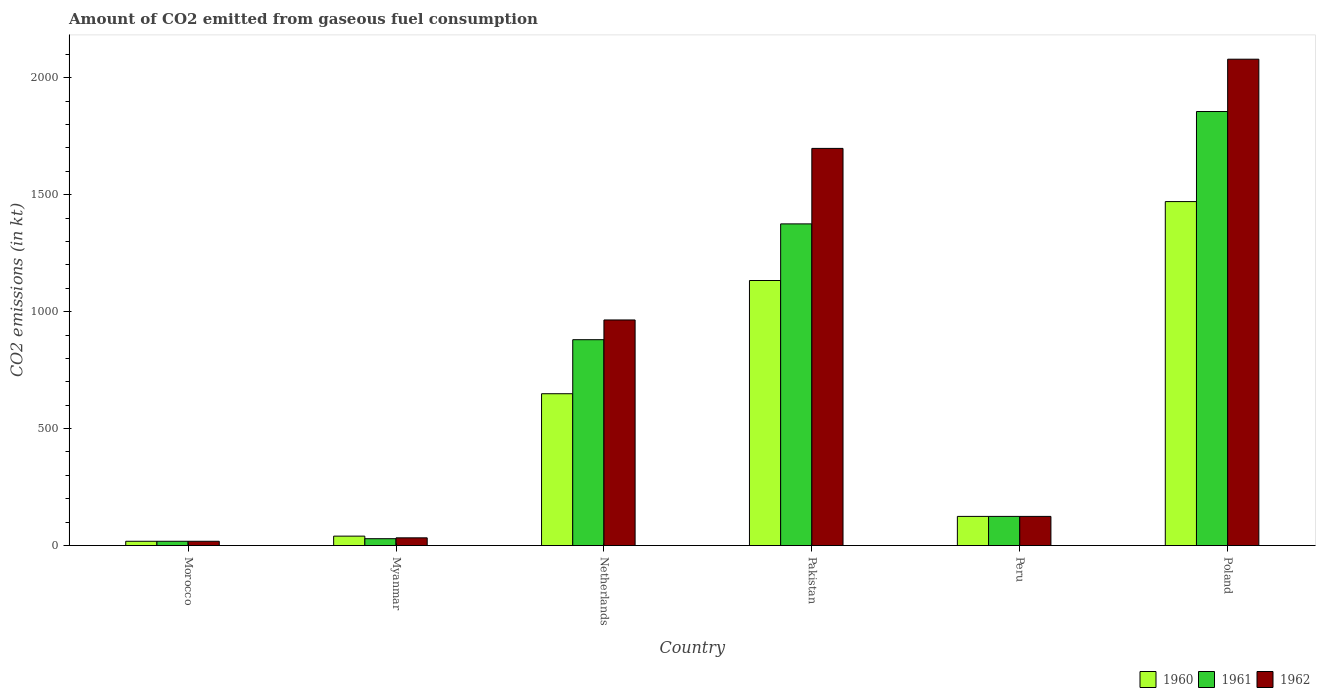Are the number of bars per tick equal to the number of legend labels?
Give a very brief answer. Yes. How many bars are there on the 5th tick from the left?
Ensure brevity in your answer.  3. What is the amount of CO2 emitted in 1962 in Pakistan?
Provide a short and direct response. 1697.82. Across all countries, what is the maximum amount of CO2 emitted in 1961?
Offer a terse response. 1855.5. Across all countries, what is the minimum amount of CO2 emitted in 1961?
Keep it short and to the point. 18.34. In which country was the amount of CO2 emitted in 1961 maximum?
Make the answer very short. Poland. In which country was the amount of CO2 emitted in 1962 minimum?
Keep it short and to the point. Morocco. What is the total amount of CO2 emitted in 1962 in the graph?
Offer a terse response. 4917.45. What is the difference between the amount of CO2 emitted in 1962 in Pakistan and that in Poland?
Your answer should be very brief. -381.37. What is the difference between the amount of CO2 emitted in 1960 in Myanmar and the amount of CO2 emitted in 1961 in Morocco?
Make the answer very short. 22. What is the average amount of CO2 emitted in 1960 per country?
Make the answer very short. 572.66. What is the difference between the amount of CO2 emitted of/in 1962 and amount of CO2 emitted of/in 1961 in Netherlands?
Ensure brevity in your answer.  84.34. In how many countries, is the amount of CO2 emitted in 1960 greater than 500 kt?
Ensure brevity in your answer.  3. What is the ratio of the amount of CO2 emitted in 1961 in Morocco to that in Peru?
Provide a succinct answer. 0.15. Is the amount of CO2 emitted in 1961 in Morocco less than that in Myanmar?
Offer a very short reply. Yes. Is the difference between the amount of CO2 emitted in 1962 in Morocco and Peru greater than the difference between the amount of CO2 emitted in 1961 in Morocco and Peru?
Keep it short and to the point. No. What is the difference between the highest and the second highest amount of CO2 emitted in 1961?
Offer a very short reply. -495.04. What is the difference between the highest and the lowest amount of CO2 emitted in 1962?
Ensure brevity in your answer.  2060.85. In how many countries, is the amount of CO2 emitted in 1960 greater than the average amount of CO2 emitted in 1960 taken over all countries?
Give a very brief answer. 3. What does the 2nd bar from the left in Myanmar represents?
Offer a very short reply. 1961. Are all the bars in the graph horizontal?
Give a very brief answer. No. Are the values on the major ticks of Y-axis written in scientific E-notation?
Provide a short and direct response. No. Does the graph contain grids?
Your answer should be very brief. No. What is the title of the graph?
Ensure brevity in your answer.  Amount of CO2 emitted from gaseous fuel consumption. What is the label or title of the X-axis?
Ensure brevity in your answer.  Country. What is the label or title of the Y-axis?
Provide a succinct answer. CO2 emissions (in kt). What is the CO2 emissions (in kt) in 1960 in Morocco?
Your answer should be compact. 18.34. What is the CO2 emissions (in kt) of 1961 in Morocco?
Your answer should be very brief. 18.34. What is the CO2 emissions (in kt) in 1962 in Morocco?
Provide a short and direct response. 18.34. What is the CO2 emissions (in kt) of 1960 in Myanmar?
Make the answer very short. 40.34. What is the CO2 emissions (in kt) in 1961 in Myanmar?
Your answer should be compact. 29.34. What is the CO2 emissions (in kt) in 1962 in Myanmar?
Your answer should be very brief. 33. What is the CO2 emissions (in kt) in 1960 in Netherlands?
Make the answer very short. 649.06. What is the CO2 emissions (in kt) of 1961 in Netherlands?
Offer a very short reply. 880.08. What is the CO2 emissions (in kt) in 1962 in Netherlands?
Provide a succinct answer. 964.42. What is the CO2 emissions (in kt) in 1960 in Pakistan?
Your response must be concise. 1133.1. What is the CO2 emissions (in kt) of 1961 in Pakistan?
Your response must be concise. 1375.12. What is the CO2 emissions (in kt) in 1962 in Pakistan?
Your answer should be very brief. 1697.82. What is the CO2 emissions (in kt) of 1960 in Peru?
Give a very brief answer. 124.68. What is the CO2 emissions (in kt) of 1961 in Peru?
Your answer should be very brief. 124.68. What is the CO2 emissions (in kt) in 1962 in Peru?
Provide a short and direct response. 124.68. What is the CO2 emissions (in kt) in 1960 in Poland?
Give a very brief answer. 1470.47. What is the CO2 emissions (in kt) in 1961 in Poland?
Offer a very short reply. 1855.5. What is the CO2 emissions (in kt) in 1962 in Poland?
Ensure brevity in your answer.  2079.19. Across all countries, what is the maximum CO2 emissions (in kt) of 1960?
Ensure brevity in your answer.  1470.47. Across all countries, what is the maximum CO2 emissions (in kt) in 1961?
Your answer should be compact. 1855.5. Across all countries, what is the maximum CO2 emissions (in kt) of 1962?
Offer a terse response. 2079.19. Across all countries, what is the minimum CO2 emissions (in kt) of 1960?
Offer a terse response. 18.34. Across all countries, what is the minimum CO2 emissions (in kt) in 1961?
Offer a terse response. 18.34. Across all countries, what is the minimum CO2 emissions (in kt) in 1962?
Give a very brief answer. 18.34. What is the total CO2 emissions (in kt) in 1960 in the graph?
Make the answer very short. 3435.98. What is the total CO2 emissions (in kt) in 1961 in the graph?
Provide a succinct answer. 4283.06. What is the total CO2 emissions (in kt) in 1962 in the graph?
Make the answer very short. 4917.45. What is the difference between the CO2 emissions (in kt) in 1960 in Morocco and that in Myanmar?
Give a very brief answer. -22. What is the difference between the CO2 emissions (in kt) of 1961 in Morocco and that in Myanmar?
Provide a short and direct response. -11. What is the difference between the CO2 emissions (in kt) in 1962 in Morocco and that in Myanmar?
Provide a short and direct response. -14.67. What is the difference between the CO2 emissions (in kt) of 1960 in Morocco and that in Netherlands?
Provide a succinct answer. -630.72. What is the difference between the CO2 emissions (in kt) in 1961 in Morocco and that in Netherlands?
Ensure brevity in your answer.  -861.75. What is the difference between the CO2 emissions (in kt) in 1962 in Morocco and that in Netherlands?
Your answer should be compact. -946.09. What is the difference between the CO2 emissions (in kt) of 1960 in Morocco and that in Pakistan?
Make the answer very short. -1114.77. What is the difference between the CO2 emissions (in kt) in 1961 in Morocco and that in Pakistan?
Your response must be concise. -1356.79. What is the difference between the CO2 emissions (in kt) of 1962 in Morocco and that in Pakistan?
Give a very brief answer. -1679.49. What is the difference between the CO2 emissions (in kt) of 1960 in Morocco and that in Peru?
Your answer should be very brief. -106.34. What is the difference between the CO2 emissions (in kt) of 1961 in Morocco and that in Peru?
Provide a succinct answer. -106.34. What is the difference between the CO2 emissions (in kt) in 1962 in Morocco and that in Peru?
Provide a succinct answer. -106.34. What is the difference between the CO2 emissions (in kt) in 1960 in Morocco and that in Poland?
Your response must be concise. -1452.13. What is the difference between the CO2 emissions (in kt) in 1961 in Morocco and that in Poland?
Provide a succinct answer. -1837.17. What is the difference between the CO2 emissions (in kt) of 1962 in Morocco and that in Poland?
Your answer should be very brief. -2060.85. What is the difference between the CO2 emissions (in kt) in 1960 in Myanmar and that in Netherlands?
Make the answer very short. -608.72. What is the difference between the CO2 emissions (in kt) of 1961 in Myanmar and that in Netherlands?
Offer a terse response. -850.74. What is the difference between the CO2 emissions (in kt) in 1962 in Myanmar and that in Netherlands?
Your answer should be compact. -931.42. What is the difference between the CO2 emissions (in kt) of 1960 in Myanmar and that in Pakistan?
Give a very brief answer. -1092.77. What is the difference between the CO2 emissions (in kt) in 1961 in Myanmar and that in Pakistan?
Give a very brief answer. -1345.79. What is the difference between the CO2 emissions (in kt) in 1962 in Myanmar and that in Pakistan?
Offer a terse response. -1664.82. What is the difference between the CO2 emissions (in kt) in 1960 in Myanmar and that in Peru?
Keep it short and to the point. -84.34. What is the difference between the CO2 emissions (in kt) in 1961 in Myanmar and that in Peru?
Your response must be concise. -95.34. What is the difference between the CO2 emissions (in kt) of 1962 in Myanmar and that in Peru?
Offer a very short reply. -91.67. What is the difference between the CO2 emissions (in kt) in 1960 in Myanmar and that in Poland?
Make the answer very short. -1430.13. What is the difference between the CO2 emissions (in kt) in 1961 in Myanmar and that in Poland?
Keep it short and to the point. -1826.17. What is the difference between the CO2 emissions (in kt) of 1962 in Myanmar and that in Poland?
Keep it short and to the point. -2046.19. What is the difference between the CO2 emissions (in kt) of 1960 in Netherlands and that in Pakistan?
Your response must be concise. -484.04. What is the difference between the CO2 emissions (in kt) in 1961 in Netherlands and that in Pakistan?
Your answer should be compact. -495.05. What is the difference between the CO2 emissions (in kt) in 1962 in Netherlands and that in Pakistan?
Give a very brief answer. -733.4. What is the difference between the CO2 emissions (in kt) in 1960 in Netherlands and that in Peru?
Offer a very short reply. 524.38. What is the difference between the CO2 emissions (in kt) in 1961 in Netherlands and that in Peru?
Ensure brevity in your answer.  755.4. What is the difference between the CO2 emissions (in kt) in 1962 in Netherlands and that in Peru?
Offer a terse response. 839.74. What is the difference between the CO2 emissions (in kt) of 1960 in Netherlands and that in Poland?
Your answer should be compact. -821.41. What is the difference between the CO2 emissions (in kt) of 1961 in Netherlands and that in Poland?
Your answer should be very brief. -975.42. What is the difference between the CO2 emissions (in kt) in 1962 in Netherlands and that in Poland?
Provide a short and direct response. -1114.77. What is the difference between the CO2 emissions (in kt) of 1960 in Pakistan and that in Peru?
Your answer should be very brief. 1008.42. What is the difference between the CO2 emissions (in kt) of 1961 in Pakistan and that in Peru?
Make the answer very short. 1250.45. What is the difference between the CO2 emissions (in kt) of 1962 in Pakistan and that in Peru?
Make the answer very short. 1573.14. What is the difference between the CO2 emissions (in kt) of 1960 in Pakistan and that in Poland?
Offer a terse response. -337.36. What is the difference between the CO2 emissions (in kt) in 1961 in Pakistan and that in Poland?
Keep it short and to the point. -480.38. What is the difference between the CO2 emissions (in kt) of 1962 in Pakistan and that in Poland?
Give a very brief answer. -381.37. What is the difference between the CO2 emissions (in kt) of 1960 in Peru and that in Poland?
Your answer should be very brief. -1345.79. What is the difference between the CO2 emissions (in kt) in 1961 in Peru and that in Poland?
Make the answer very short. -1730.82. What is the difference between the CO2 emissions (in kt) of 1962 in Peru and that in Poland?
Provide a succinct answer. -1954.51. What is the difference between the CO2 emissions (in kt) in 1960 in Morocco and the CO2 emissions (in kt) in 1961 in Myanmar?
Offer a very short reply. -11. What is the difference between the CO2 emissions (in kt) of 1960 in Morocco and the CO2 emissions (in kt) of 1962 in Myanmar?
Your response must be concise. -14.67. What is the difference between the CO2 emissions (in kt) in 1961 in Morocco and the CO2 emissions (in kt) in 1962 in Myanmar?
Make the answer very short. -14.67. What is the difference between the CO2 emissions (in kt) in 1960 in Morocco and the CO2 emissions (in kt) in 1961 in Netherlands?
Your response must be concise. -861.75. What is the difference between the CO2 emissions (in kt) in 1960 in Morocco and the CO2 emissions (in kt) in 1962 in Netherlands?
Give a very brief answer. -946.09. What is the difference between the CO2 emissions (in kt) of 1961 in Morocco and the CO2 emissions (in kt) of 1962 in Netherlands?
Provide a short and direct response. -946.09. What is the difference between the CO2 emissions (in kt) in 1960 in Morocco and the CO2 emissions (in kt) in 1961 in Pakistan?
Offer a very short reply. -1356.79. What is the difference between the CO2 emissions (in kt) in 1960 in Morocco and the CO2 emissions (in kt) in 1962 in Pakistan?
Make the answer very short. -1679.49. What is the difference between the CO2 emissions (in kt) of 1961 in Morocco and the CO2 emissions (in kt) of 1962 in Pakistan?
Your answer should be very brief. -1679.49. What is the difference between the CO2 emissions (in kt) in 1960 in Morocco and the CO2 emissions (in kt) in 1961 in Peru?
Offer a very short reply. -106.34. What is the difference between the CO2 emissions (in kt) in 1960 in Morocco and the CO2 emissions (in kt) in 1962 in Peru?
Your answer should be very brief. -106.34. What is the difference between the CO2 emissions (in kt) of 1961 in Morocco and the CO2 emissions (in kt) of 1962 in Peru?
Offer a terse response. -106.34. What is the difference between the CO2 emissions (in kt) of 1960 in Morocco and the CO2 emissions (in kt) of 1961 in Poland?
Keep it short and to the point. -1837.17. What is the difference between the CO2 emissions (in kt) in 1960 in Morocco and the CO2 emissions (in kt) in 1962 in Poland?
Ensure brevity in your answer.  -2060.85. What is the difference between the CO2 emissions (in kt) of 1961 in Morocco and the CO2 emissions (in kt) of 1962 in Poland?
Offer a terse response. -2060.85. What is the difference between the CO2 emissions (in kt) in 1960 in Myanmar and the CO2 emissions (in kt) in 1961 in Netherlands?
Ensure brevity in your answer.  -839.74. What is the difference between the CO2 emissions (in kt) of 1960 in Myanmar and the CO2 emissions (in kt) of 1962 in Netherlands?
Your response must be concise. -924.08. What is the difference between the CO2 emissions (in kt) in 1961 in Myanmar and the CO2 emissions (in kt) in 1962 in Netherlands?
Your answer should be very brief. -935.09. What is the difference between the CO2 emissions (in kt) in 1960 in Myanmar and the CO2 emissions (in kt) in 1961 in Pakistan?
Your answer should be compact. -1334.79. What is the difference between the CO2 emissions (in kt) in 1960 in Myanmar and the CO2 emissions (in kt) in 1962 in Pakistan?
Offer a terse response. -1657.48. What is the difference between the CO2 emissions (in kt) in 1961 in Myanmar and the CO2 emissions (in kt) in 1962 in Pakistan?
Make the answer very short. -1668.48. What is the difference between the CO2 emissions (in kt) of 1960 in Myanmar and the CO2 emissions (in kt) of 1961 in Peru?
Make the answer very short. -84.34. What is the difference between the CO2 emissions (in kt) of 1960 in Myanmar and the CO2 emissions (in kt) of 1962 in Peru?
Keep it short and to the point. -84.34. What is the difference between the CO2 emissions (in kt) in 1961 in Myanmar and the CO2 emissions (in kt) in 1962 in Peru?
Give a very brief answer. -95.34. What is the difference between the CO2 emissions (in kt) of 1960 in Myanmar and the CO2 emissions (in kt) of 1961 in Poland?
Give a very brief answer. -1815.16. What is the difference between the CO2 emissions (in kt) of 1960 in Myanmar and the CO2 emissions (in kt) of 1962 in Poland?
Offer a terse response. -2038.85. What is the difference between the CO2 emissions (in kt) in 1961 in Myanmar and the CO2 emissions (in kt) in 1962 in Poland?
Your answer should be compact. -2049.85. What is the difference between the CO2 emissions (in kt) of 1960 in Netherlands and the CO2 emissions (in kt) of 1961 in Pakistan?
Make the answer very short. -726.07. What is the difference between the CO2 emissions (in kt) in 1960 in Netherlands and the CO2 emissions (in kt) in 1962 in Pakistan?
Your answer should be very brief. -1048.76. What is the difference between the CO2 emissions (in kt) of 1961 in Netherlands and the CO2 emissions (in kt) of 1962 in Pakistan?
Keep it short and to the point. -817.74. What is the difference between the CO2 emissions (in kt) in 1960 in Netherlands and the CO2 emissions (in kt) in 1961 in Peru?
Give a very brief answer. 524.38. What is the difference between the CO2 emissions (in kt) of 1960 in Netherlands and the CO2 emissions (in kt) of 1962 in Peru?
Keep it short and to the point. 524.38. What is the difference between the CO2 emissions (in kt) in 1961 in Netherlands and the CO2 emissions (in kt) in 1962 in Peru?
Ensure brevity in your answer.  755.4. What is the difference between the CO2 emissions (in kt) of 1960 in Netherlands and the CO2 emissions (in kt) of 1961 in Poland?
Provide a succinct answer. -1206.44. What is the difference between the CO2 emissions (in kt) in 1960 in Netherlands and the CO2 emissions (in kt) in 1962 in Poland?
Offer a very short reply. -1430.13. What is the difference between the CO2 emissions (in kt) in 1961 in Netherlands and the CO2 emissions (in kt) in 1962 in Poland?
Your response must be concise. -1199.11. What is the difference between the CO2 emissions (in kt) in 1960 in Pakistan and the CO2 emissions (in kt) in 1961 in Peru?
Your response must be concise. 1008.42. What is the difference between the CO2 emissions (in kt) in 1960 in Pakistan and the CO2 emissions (in kt) in 1962 in Peru?
Offer a terse response. 1008.42. What is the difference between the CO2 emissions (in kt) of 1961 in Pakistan and the CO2 emissions (in kt) of 1962 in Peru?
Offer a terse response. 1250.45. What is the difference between the CO2 emissions (in kt) of 1960 in Pakistan and the CO2 emissions (in kt) of 1961 in Poland?
Give a very brief answer. -722.4. What is the difference between the CO2 emissions (in kt) of 1960 in Pakistan and the CO2 emissions (in kt) of 1962 in Poland?
Make the answer very short. -946.09. What is the difference between the CO2 emissions (in kt) in 1961 in Pakistan and the CO2 emissions (in kt) in 1962 in Poland?
Your answer should be compact. -704.06. What is the difference between the CO2 emissions (in kt) in 1960 in Peru and the CO2 emissions (in kt) in 1961 in Poland?
Provide a succinct answer. -1730.82. What is the difference between the CO2 emissions (in kt) in 1960 in Peru and the CO2 emissions (in kt) in 1962 in Poland?
Provide a succinct answer. -1954.51. What is the difference between the CO2 emissions (in kt) in 1961 in Peru and the CO2 emissions (in kt) in 1962 in Poland?
Ensure brevity in your answer.  -1954.51. What is the average CO2 emissions (in kt) of 1960 per country?
Offer a terse response. 572.66. What is the average CO2 emissions (in kt) of 1961 per country?
Give a very brief answer. 713.84. What is the average CO2 emissions (in kt) in 1962 per country?
Your answer should be compact. 819.57. What is the difference between the CO2 emissions (in kt) of 1960 and CO2 emissions (in kt) of 1961 in Myanmar?
Your response must be concise. 11. What is the difference between the CO2 emissions (in kt) of 1960 and CO2 emissions (in kt) of 1962 in Myanmar?
Ensure brevity in your answer.  7.33. What is the difference between the CO2 emissions (in kt) in 1961 and CO2 emissions (in kt) in 1962 in Myanmar?
Make the answer very short. -3.67. What is the difference between the CO2 emissions (in kt) in 1960 and CO2 emissions (in kt) in 1961 in Netherlands?
Offer a very short reply. -231.02. What is the difference between the CO2 emissions (in kt) in 1960 and CO2 emissions (in kt) in 1962 in Netherlands?
Offer a very short reply. -315.36. What is the difference between the CO2 emissions (in kt) in 1961 and CO2 emissions (in kt) in 1962 in Netherlands?
Your response must be concise. -84.34. What is the difference between the CO2 emissions (in kt) of 1960 and CO2 emissions (in kt) of 1961 in Pakistan?
Your answer should be very brief. -242.02. What is the difference between the CO2 emissions (in kt) of 1960 and CO2 emissions (in kt) of 1962 in Pakistan?
Offer a terse response. -564.72. What is the difference between the CO2 emissions (in kt) of 1961 and CO2 emissions (in kt) of 1962 in Pakistan?
Offer a terse response. -322.7. What is the difference between the CO2 emissions (in kt) of 1960 and CO2 emissions (in kt) of 1961 in Peru?
Ensure brevity in your answer.  0. What is the difference between the CO2 emissions (in kt) of 1960 and CO2 emissions (in kt) of 1962 in Peru?
Offer a very short reply. 0. What is the difference between the CO2 emissions (in kt) of 1961 and CO2 emissions (in kt) of 1962 in Peru?
Make the answer very short. 0. What is the difference between the CO2 emissions (in kt) in 1960 and CO2 emissions (in kt) in 1961 in Poland?
Provide a short and direct response. -385.04. What is the difference between the CO2 emissions (in kt) of 1960 and CO2 emissions (in kt) of 1962 in Poland?
Ensure brevity in your answer.  -608.72. What is the difference between the CO2 emissions (in kt) in 1961 and CO2 emissions (in kt) in 1962 in Poland?
Your answer should be very brief. -223.69. What is the ratio of the CO2 emissions (in kt) of 1960 in Morocco to that in Myanmar?
Your response must be concise. 0.45. What is the ratio of the CO2 emissions (in kt) in 1962 in Morocco to that in Myanmar?
Your answer should be compact. 0.56. What is the ratio of the CO2 emissions (in kt) of 1960 in Morocco to that in Netherlands?
Your response must be concise. 0.03. What is the ratio of the CO2 emissions (in kt) of 1961 in Morocco to that in Netherlands?
Provide a succinct answer. 0.02. What is the ratio of the CO2 emissions (in kt) in 1962 in Morocco to that in Netherlands?
Your response must be concise. 0.02. What is the ratio of the CO2 emissions (in kt) in 1960 in Morocco to that in Pakistan?
Keep it short and to the point. 0.02. What is the ratio of the CO2 emissions (in kt) of 1961 in Morocco to that in Pakistan?
Provide a succinct answer. 0.01. What is the ratio of the CO2 emissions (in kt) in 1962 in Morocco to that in Pakistan?
Your answer should be very brief. 0.01. What is the ratio of the CO2 emissions (in kt) in 1960 in Morocco to that in Peru?
Make the answer very short. 0.15. What is the ratio of the CO2 emissions (in kt) of 1961 in Morocco to that in Peru?
Provide a succinct answer. 0.15. What is the ratio of the CO2 emissions (in kt) of 1962 in Morocco to that in Peru?
Offer a very short reply. 0.15. What is the ratio of the CO2 emissions (in kt) of 1960 in Morocco to that in Poland?
Make the answer very short. 0.01. What is the ratio of the CO2 emissions (in kt) in 1961 in Morocco to that in Poland?
Provide a succinct answer. 0.01. What is the ratio of the CO2 emissions (in kt) in 1962 in Morocco to that in Poland?
Keep it short and to the point. 0.01. What is the ratio of the CO2 emissions (in kt) in 1960 in Myanmar to that in Netherlands?
Make the answer very short. 0.06. What is the ratio of the CO2 emissions (in kt) in 1962 in Myanmar to that in Netherlands?
Offer a terse response. 0.03. What is the ratio of the CO2 emissions (in kt) of 1960 in Myanmar to that in Pakistan?
Your response must be concise. 0.04. What is the ratio of the CO2 emissions (in kt) in 1961 in Myanmar to that in Pakistan?
Provide a succinct answer. 0.02. What is the ratio of the CO2 emissions (in kt) of 1962 in Myanmar to that in Pakistan?
Your answer should be compact. 0.02. What is the ratio of the CO2 emissions (in kt) of 1960 in Myanmar to that in Peru?
Make the answer very short. 0.32. What is the ratio of the CO2 emissions (in kt) of 1961 in Myanmar to that in Peru?
Your answer should be very brief. 0.24. What is the ratio of the CO2 emissions (in kt) of 1962 in Myanmar to that in Peru?
Give a very brief answer. 0.26. What is the ratio of the CO2 emissions (in kt) in 1960 in Myanmar to that in Poland?
Provide a succinct answer. 0.03. What is the ratio of the CO2 emissions (in kt) in 1961 in Myanmar to that in Poland?
Make the answer very short. 0.02. What is the ratio of the CO2 emissions (in kt) of 1962 in Myanmar to that in Poland?
Make the answer very short. 0.02. What is the ratio of the CO2 emissions (in kt) of 1960 in Netherlands to that in Pakistan?
Provide a succinct answer. 0.57. What is the ratio of the CO2 emissions (in kt) of 1961 in Netherlands to that in Pakistan?
Provide a succinct answer. 0.64. What is the ratio of the CO2 emissions (in kt) of 1962 in Netherlands to that in Pakistan?
Make the answer very short. 0.57. What is the ratio of the CO2 emissions (in kt) of 1960 in Netherlands to that in Peru?
Ensure brevity in your answer.  5.21. What is the ratio of the CO2 emissions (in kt) of 1961 in Netherlands to that in Peru?
Keep it short and to the point. 7.06. What is the ratio of the CO2 emissions (in kt) of 1962 in Netherlands to that in Peru?
Your response must be concise. 7.74. What is the ratio of the CO2 emissions (in kt) of 1960 in Netherlands to that in Poland?
Your response must be concise. 0.44. What is the ratio of the CO2 emissions (in kt) of 1961 in Netherlands to that in Poland?
Offer a very short reply. 0.47. What is the ratio of the CO2 emissions (in kt) in 1962 in Netherlands to that in Poland?
Offer a terse response. 0.46. What is the ratio of the CO2 emissions (in kt) in 1960 in Pakistan to that in Peru?
Offer a terse response. 9.09. What is the ratio of the CO2 emissions (in kt) in 1961 in Pakistan to that in Peru?
Ensure brevity in your answer.  11.03. What is the ratio of the CO2 emissions (in kt) of 1962 in Pakistan to that in Peru?
Ensure brevity in your answer.  13.62. What is the ratio of the CO2 emissions (in kt) in 1960 in Pakistan to that in Poland?
Ensure brevity in your answer.  0.77. What is the ratio of the CO2 emissions (in kt) of 1961 in Pakistan to that in Poland?
Your answer should be very brief. 0.74. What is the ratio of the CO2 emissions (in kt) in 1962 in Pakistan to that in Poland?
Your answer should be very brief. 0.82. What is the ratio of the CO2 emissions (in kt) of 1960 in Peru to that in Poland?
Keep it short and to the point. 0.08. What is the ratio of the CO2 emissions (in kt) of 1961 in Peru to that in Poland?
Keep it short and to the point. 0.07. What is the ratio of the CO2 emissions (in kt) of 1962 in Peru to that in Poland?
Your response must be concise. 0.06. What is the difference between the highest and the second highest CO2 emissions (in kt) in 1960?
Provide a succinct answer. 337.36. What is the difference between the highest and the second highest CO2 emissions (in kt) of 1961?
Your response must be concise. 480.38. What is the difference between the highest and the second highest CO2 emissions (in kt) of 1962?
Offer a very short reply. 381.37. What is the difference between the highest and the lowest CO2 emissions (in kt) of 1960?
Offer a terse response. 1452.13. What is the difference between the highest and the lowest CO2 emissions (in kt) in 1961?
Ensure brevity in your answer.  1837.17. What is the difference between the highest and the lowest CO2 emissions (in kt) of 1962?
Your answer should be compact. 2060.85. 